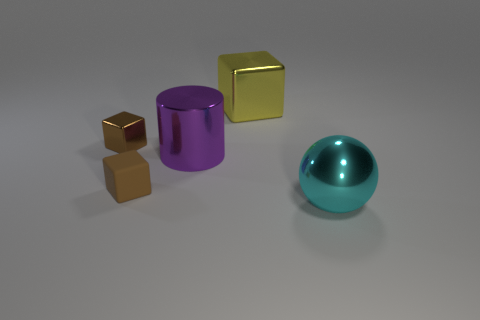How many purple objects are large metal cylinders or small metal things?
Offer a terse response. 1. What shape is the tiny object that is right of the small block that is behind the small block in front of the brown metallic thing?
Provide a succinct answer. Cube. The cube that is the same size as the purple metallic thing is what color?
Ensure brevity in your answer.  Yellow. How many cyan metal things are the same shape as the purple thing?
Keep it short and to the point. 0. Does the purple object have the same size as the metal block that is to the left of the large yellow metal object?
Your response must be concise. No. What is the shape of the large thing left of the large object that is behind the brown metal thing?
Your answer should be very brief. Cylinder. Is the number of big purple shiny cylinders left of the purple thing less than the number of cylinders?
Provide a succinct answer. Yes. What shape is the other small thing that is the same color as the small rubber object?
Keep it short and to the point. Cube. What number of purple cylinders are the same size as the brown matte cube?
Make the answer very short. 0. There is a object right of the yellow object; what is its shape?
Give a very brief answer. Sphere. 